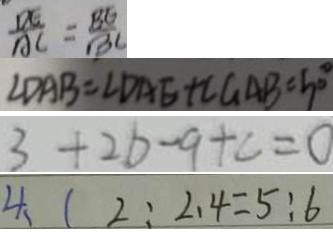<formula> <loc_0><loc_0><loc_500><loc_500>\frac { D E } { A C } = \frac { B E } { B C } 
 \angle D A B = \angle D A E + \angle G A B = 5 0 ^ { \circ } 
 3 + 2 b - 9 + c = 0 
 4 、 ( 2 : 2 . 4 = 5 : 6</formula> 